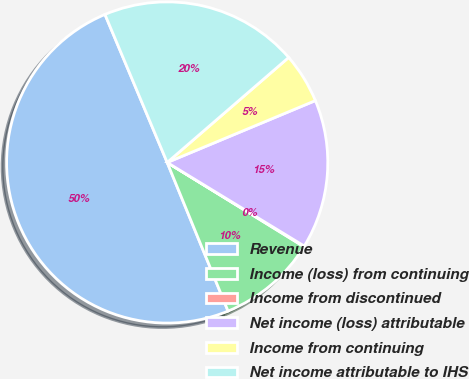<chart> <loc_0><loc_0><loc_500><loc_500><pie_chart><fcel>Revenue<fcel>Income (loss) from continuing<fcel>Income from discontinued<fcel>Net income (loss) attributable<fcel>Income from continuing<fcel>Net income attributable to IHS<nl><fcel>49.86%<fcel>10.03%<fcel>0.07%<fcel>15.01%<fcel>5.05%<fcel>19.99%<nl></chart> 